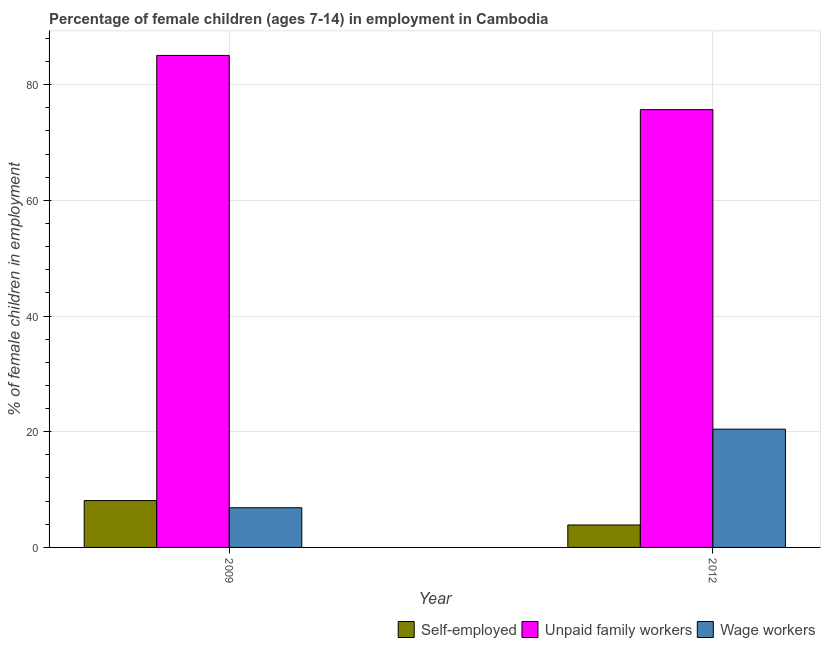Are the number of bars per tick equal to the number of legend labels?
Keep it short and to the point. Yes. What is the percentage of children employed as unpaid family workers in 2012?
Your answer should be very brief. 75.67. Across all years, what is the maximum percentage of self employed children?
Provide a short and direct response. 8.1. Across all years, what is the minimum percentage of self employed children?
Your answer should be compact. 3.88. In which year was the percentage of children employed as wage workers minimum?
Provide a short and direct response. 2009. What is the total percentage of self employed children in the graph?
Your response must be concise. 11.98. What is the difference between the percentage of children employed as unpaid family workers in 2009 and that in 2012?
Give a very brief answer. 9.37. What is the difference between the percentage of children employed as unpaid family workers in 2012 and the percentage of self employed children in 2009?
Your answer should be very brief. -9.37. What is the average percentage of children employed as wage workers per year?
Give a very brief answer. 13.65. In how many years, is the percentage of self employed children greater than 64 %?
Offer a very short reply. 0. What is the ratio of the percentage of self employed children in 2009 to that in 2012?
Provide a succinct answer. 2.09. What does the 1st bar from the left in 2009 represents?
Your response must be concise. Self-employed. What does the 2nd bar from the right in 2012 represents?
Make the answer very short. Unpaid family workers. How many bars are there?
Provide a succinct answer. 6. Are all the bars in the graph horizontal?
Offer a terse response. No. How many years are there in the graph?
Provide a succinct answer. 2. Are the values on the major ticks of Y-axis written in scientific E-notation?
Provide a short and direct response. No. What is the title of the graph?
Give a very brief answer. Percentage of female children (ages 7-14) in employment in Cambodia. What is the label or title of the Y-axis?
Your answer should be compact. % of female children in employment. What is the % of female children in employment of Unpaid family workers in 2009?
Make the answer very short. 85.04. What is the % of female children in employment of Wage workers in 2009?
Provide a succinct answer. 6.86. What is the % of female children in employment of Self-employed in 2012?
Your response must be concise. 3.88. What is the % of female children in employment in Unpaid family workers in 2012?
Your answer should be compact. 75.67. What is the % of female children in employment of Wage workers in 2012?
Make the answer very short. 20.44. Across all years, what is the maximum % of female children in employment of Self-employed?
Give a very brief answer. 8.1. Across all years, what is the maximum % of female children in employment of Unpaid family workers?
Your response must be concise. 85.04. Across all years, what is the maximum % of female children in employment of Wage workers?
Provide a succinct answer. 20.44. Across all years, what is the minimum % of female children in employment of Self-employed?
Keep it short and to the point. 3.88. Across all years, what is the minimum % of female children in employment of Unpaid family workers?
Your answer should be compact. 75.67. Across all years, what is the minimum % of female children in employment in Wage workers?
Provide a succinct answer. 6.86. What is the total % of female children in employment in Self-employed in the graph?
Your response must be concise. 11.98. What is the total % of female children in employment of Unpaid family workers in the graph?
Offer a very short reply. 160.71. What is the total % of female children in employment in Wage workers in the graph?
Provide a short and direct response. 27.3. What is the difference between the % of female children in employment in Self-employed in 2009 and that in 2012?
Offer a very short reply. 4.22. What is the difference between the % of female children in employment in Unpaid family workers in 2009 and that in 2012?
Make the answer very short. 9.37. What is the difference between the % of female children in employment in Wage workers in 2009 and that in 2012?
Provide a short and direct response. -13.58. What is the difference between the % of female children in employment in Self-employed in 2009 and the % of female children in employment in Unpaid family workers in 2012?
Your answer should be compact. -67.57. What is the difference between the % of female children in employment in Self-employed in 2009 and the % of female children in employment in Wage workers in 2012?
Provide a succinct answer. -12.34. What is the difference between the % of female children in employment of Unpaid family workers in 2009 and the % of female children in employment of Wage workers in 2012?
Give a very brief answer. 64.6. What is the average % of female children in employment in Self-employed per year?
Provide a succinct answer. 5.99. What is the average % of female children in employment in Unpaid family workers per year?
Offer a very short reply. 80.36. What is the average % of female children in employment of Wage workers per year?
Keep it short and to the point. 13.65. In the year 2009, what is the difference between the % of female children in employment in Self-employed and % of female children in employment in Unpaid family workers?
Make the answer very short. -76.94. In the year 2009, what is the difference between the % of female children in employment in Self-employed and % of female children in employment in Wage workers?
Ensure brevity in your answer.  1.24. In the year 2009, what is the difference between the % of female children in employment of Unpaid family workers and % of female children in employment of Wage workers?
Provide a short and direct response. 78.18. In the year 2012, what is the difference between the % of female children in employment in Self-employed and % of female children in employment in Unpaid family workers?
Offer a terse response. -71.79. In the year 2012, what is the difference between the % of female children in employment of Self-employed and % of female children in employment of Wage workers?
Offer a very short reply. -16.56. In the year 2012, what is the difference between the % of female children in employment of Unpaid family workers and % of female children in employment of Wage workers?
Give a very brief answer. 55.23. What is the ratio of the % of female children in employment of Self-employed in 2009 to that in 2012?
Ensure brevity in your answer.  2.09. What is the ratio of the % of female children in employment of Unpaid family workers in 2009 to that in 2012?
Offer a very short reply. 1.12. What is the ratio of the % of female children in employment in Wage workers in 2009 to that in 2012?
Offer a very short reply. 0.34. What is the difference between the highest and the second highest % of female children in employment of Self-employed?
Your answer should be compact. 4.22. What is the difference between the highest and the second highest % of female children in employment in Unpaid family workers?
Keep it short and to the point. 9.37. What is the difference between the highest and the second highest % of female children in employment of Wage workers?
Ensure brevity in your answer.  13.58. What is the difference between the highest and the lowest % of female children in employment in Self-employed?
Your answer should be very brief. 4.22. What is the difference between the highest and the lowest % of female children in employment in Unpaid family workers?
Your answer should be very brief. 9.37. What is the difference between the highest and the lowest % of female children in employment in Wage workers?
Your response must be concise. 13.58. 